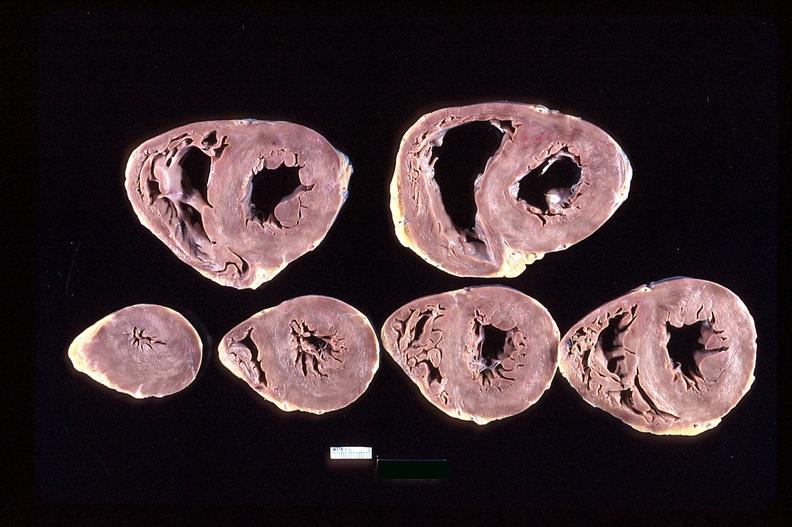what does this image show?
Answer the question using a single word or phrase. Heart slices 